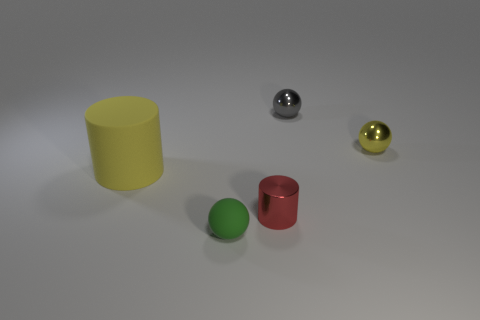Subtract all tiny shiny balls. How many balls are left? 1 Add 3 matte things. How many objects exist? 8 Subtract all purple balls. Subtract all brown cylinders. How many balls are left? 3 Subtract 0 green cubes. How many objects are left? 5 Subtract all cylinders. How many objects are left? 3 Subtract all metallic objects. Subtract all big green shiny balls. How many objects are left? 2 Add 1 large yellow matte objects. How many large yellow matte objects are left? 2 Add 5 small green objects. How many small green objects exist? 6 